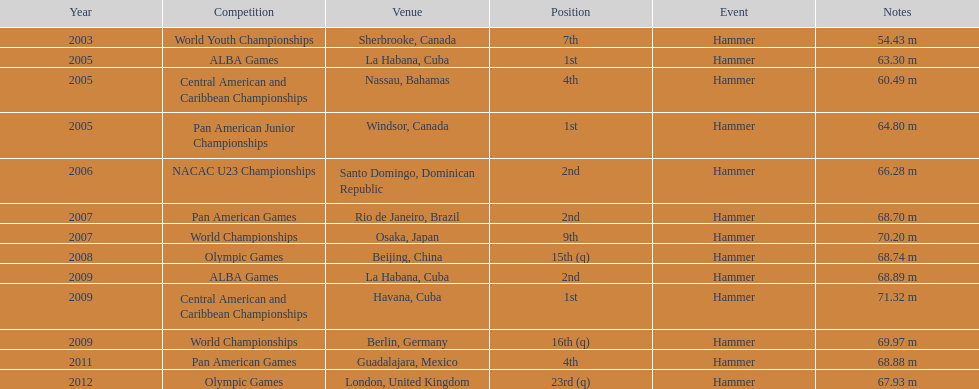During which olympic games did arasay thondike not rank in the top 20? 2012. 